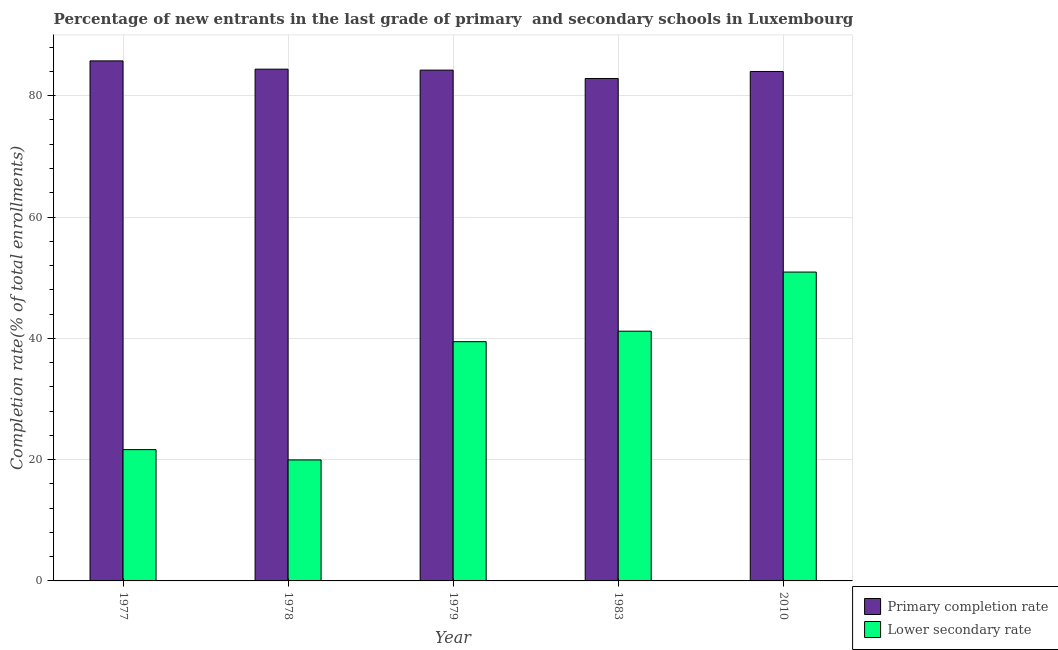How many groups of bars are there?
Your answer should be compact. 5. Are the number of bars per tick equal to the number of legend labels?
Keep it short and to the point. Yes. How many bars are there on the 5th tick from the right?
Provide a short and direct response. 2. What is the completion rate in primary schools in 1978?
Provide a succinct answer. 84.38. Across all years, what is the maximum completion rate in primary schools?
Your answer should be compact. 85.74. Across all years, what is the minimum completion rate in secondary schools?
Offer a terse response. 19.95. In which year was the completion rate in secondary schools minimum?
Your answer should be very brief. 1978. What is the total completion rate in secondary schools in the graph?
Keep it short and to the point. 173.15. What is the difference between the completion rate in secondary schools in 1977 and that in 2010?
Keep it short and to the point. -29.27. What is the difference between the completion rate in secondary schools in 1977 and the completion rate in primary schools in 1983?
Your response must be concise. -19.53. What is the average completion rate in primary schools per year?
Provide a succinct answer. 84.24. In the year 2010, what is the difference between the completion rate in secondary schools and completion rate in primary schools?
Your response must be concise. 0. In how many years, is the completion rate in secondary schools greater than 48 %?
Your answer should be compact. 1. What is the ratio of the completion rate in secondary schools in 1977 to that in 1978?
Ensure brevity in your answer.  1.09. Is the completion rate in primary schools in 1979 less than that in 2010?
Ensure brevity in your answer.  No. What is the difference between the highest and the second highest completion rate in primary schools?
Offer a terse response. 1.37. What is the difference between the highest and the lowest completion rate in secondary schools?
Your answer should be compact. 30.97. Is the sum of the completion rate in secondary schools in 1977 and 2010 greater than the maximum completion rate in primary schools across all years?
Offer a terse response. Yes. What does the 1st bar from the left in 1983 represents?
Provide a succinct answer. Primary completion rate. What does the 2nd bar from the right in 1979 represents?
Your answer should be compact. Primary completion rate. How many bars are there?
Give a very brief answer. 10. How many years are there in the graph?
Keep it short and to the point. 5. What is the difference between two consecutive major ticks on the Y-axis?
Your answer should be very brief. 20. Does the graph contain any zero values?
Offer a very short reply. No. Does the graph contain grids?
Provide a short and direct response. Yes. How many legend labels are there?
Ensure brevity in your answer.  2. How are the legend labels stacked?
Offer a terse response. Vertical. What is the title of the graph?
Your answer should be very brief. Percentage of new entrants in the last grade of primary  and secondary schools in Luxembourg. Does "Passenger Transport Items" appear as one of the legend labels in the graph?
Keep it short and to the point. No. What is the label or title of the X-axis?
Make the answer very short. Year. What is the label or title of the Y-axis?
Your answer should be compact. Completion rate(% of total enrollments). What is the Completion rate(% of total enrollments) of Primary completion rate in 1977?
Provide a succinct answer. 85.74. What is the Completion rate(% of total enrollments) of Lower secondary rate in 1977?
Keep it short and to the point. 21.65. What is the Completion rate(% of total enrollments) of Primary completion rate in 1978?
Make the answer very short. 84.38. What is the Completion rate(% of total enrollments) of Lower secondary rate in 1978?
Ensure brevity in your answer.  19.95. What is the Completion rate(% of total enrollments) of Primary completion rate in 1979?
Offer a terse response. 84.22. What is the Completion rate(% of total enrollments) of Lower secondary rate in 1979?
Your answer should be compact. 39.45. What is the Completion rate(% of total enrollments) of Primary completion rate in 1983?
Provide a succinct answer. 82.84. What is the Completion rate(% of total enrollments) of Lower secondary rate in 1983?
Make the answer very short. 41.18. What is the Completion rate(% of total enrollments) of Primary completion rate in 2010?
Your answer should be very brief. 84. What is the Completion rate(% of total enrollments) in Lower secondary rate in 2010?
Your answer should be very brief. 50.92. Across all years, what is the maximum Completion rate(% of total enrollments) in Primary completion rate?
Your response must be concise. 85.74. Across all years, what is the maximum Completion rate(% of total enrollments) of Lower secondary rate?
Provide a succinct answer. 50.92. Across all years, what is the minimum Completion rate(% of total enrollments) in Primary completion rate?
Offer a terse response. 82.84. Across all years, what is the minimum Completion rate(% of total enrollments) in Lower secondary rate?
Your answer should be compact. 19.95. What is the total Completion rate(% of total enrollments) of Primary completion rate in the graph?
Your response must be concise. 421.18. What is the total Completion rate(% of total enrollments) in Lower secondary rate in the graph?
Provide a succinct answer. 173.15. What is the difference between the Completion rate(% of total enrollments) of Primary completion rate in 1977 and that in 1978?
Offer a very short reply. 1.37. What is the difference between the Completion rate(% of total enrollments) of Lower secondary rate in 1977 and that in 1978?
Provide a short and direct response. 1.7. What is the difference between the Completion rate(% of total enrollments) in Primary completion rate in 1977 and that in 1979?
Provide a short and direct response. 1.52. What is the difference between the Completion rate(% of total enrollments) in Lower secondary rate in 1977 and that in 1979?
Keep it short and to the point. -17.8. What is the difference between the Completion rate(% of total enrollments) in Primary completion rate in 1977 and that in 1983?
Offer a terse response. 2.9. What is the difference between the Completion rate(% of total enrollments) in Lower secondary rate in 1977 and that in 1983?
Ensure brevity in your answer.  -19.53. What is the difference between the Completion rate(% of total enrollments) of Primary completion rate in 1977 and that in 2010?
Keep it short and to the point. 1.75. What is the difference between the Completion rate(% of total enrollments) of Lower secondary rate in 1977 and that in 2010?
Make the answer very short. -29.27. What is the difference between the Completion rate(% of total enrollments) in Primary completion rate in 1978 and that in 1979?
Your response must be concise. 0.15. What is the difference between the Completion rate(% of total enrollments) of Lower secondary rate in 1978 and that in 1979?
Offer a very short reply. -19.5. What is the difference between the Completion rate(% of total enrollments) of Primary completion rate in 1978 and that in 1983?
Ensure brevity in your answer.  1.54. What is the difference between the Completion rate(% of total enrollments) in Lower secondary rate in 1978 and that in 1983?
Give a very brief answer. -21.22. What is the difference between the Completion rate(% of total enrollments) of Primary completion rate in 1978 and that in 2010?
Give a very brief answer. 0.38. What is the difference between the Completion rate(% of total enrollments) of Lower secondary rate in 1978 and that in 2010?
Provide a succinct answer. -30.97. What is the difference between the Completion rate(% of total enrollments) of Primary completion rate in 1979 and that in 1983?
Keep it short and to the point. 1.38. What is the difference between the Completion rate(% of total enrollments) in Lower secondary rate in 1979 and that in 1983?
Offer a terse response. -1.73. What is the difference between the Completion rate(% of total enrollments) of Primary completion rate in 1979 and that in 2010?
Offer a terse response. 0.23. What is the difference between the Completion rate(% of total enrollments) in Lower secondary rate in 1979 and that in 2010?
Your answer should be very brief. -11.48. What is the difference between the Completion rate(% of total enrollments) in Primary completion rate in 1983 and that in 2010?
Offer a terse response. -1.16. What is the difference between the Completion rate(% of total enrollments) in Lower secondary rate in 1983 and that in 2010?
Provide a short and direct response. -9.75. What is the difference between the Completion rate(% of total enrollments) of Primary completion rate in 1977 and the Completion rate(% of total enrollments) of Lower secondary rate in 1978?
Your response must be concise. 65.79. What is the difference between the Completion rate(% of total enrollments) in Primary completion rate in 1977 and the Completion rate(% of total enrollments) in Lower secondary rate in 1979?
Your answer should be very brief. 46.3. What is the difference between the Completion rate(% of total enrollments) in Primary completion rate in 1977 and the Completion rate(% of total enrollments) in Lower secondary rate in 1983?
Your answer should be very brief. 44.57. What is the difference between the Completion rate(% of total enrollments) in Primary completion rate in 1977 and the Completion rate(% of total enrollments) in Lower secondary rate in 2010?
Keep it short and to the point. 34.82. What is the difference between the Completion rate(% of total enrollments) in Primary completion rate in 1978 and the Completion rate(% of total enrollments) in Lower secondary rate in 1979?
Keep it short and to the point. 44.93. What is the difference between the Completion rate(% of total enrollments) in Primary completion rate in 1978 and the Completion rate(% of total enrollments) in Lower secondary rate in 1983?
Provide a succinct answer. 43.2. What is the difference between the Completion rate(% of total enrollments) of Primary completion rate in 1978 and the Completion rate(% of total enrollments) of Lower secondary rate in 2010?
Give a very brief answer. 33.45. What is the difference between the Completion rate(% of total enrollments) in Primary completion rate in 1979 and the Completion rate(% of total enrollments) in Lower secondary rate in 1983?
Ensure brevity in your answer.  43.05. What is the difference between the Completion rate(% of total enrollments) of Primary completion rate in 1979 and the Completion rate(% of total enrollments) of Lower secondary rate in 2010?
Make the answer very short. 33.3. What is the difference between the Completion rate(% of total enrollments) in Primary completion rate in 1983 and the Completion rate(% of total enrollments) in Lower secondary rate in 2010?
Provide a succinct answer. 31.92. What is the average Completion rate(% of total enrollments) of Primary completion rate per year?
Your answer should be compact. 84.24. What is the average Completion rate(% of total enrollments) of Lower secondary rate per year?
Ensure brevity in your answer.  34.63. In the year 1977, what is the difference between the Completion rate(% of total enrollments) in Primary completion rate and Completion rate(% of total enrollments) in Lower secondary rate?
Keep it short and to the point. 64.09. In the year 1978, what is the difference between the Completion rate(% of total enrollments) in Primary completion rate and Completion rate(% of total enrollments) in Lower secondary rate?
Your answer should be compact. 64.43. In the year 1979, what is the difference between the Completion rate(% of total enrollments) in Primary completion rate and Completion rate(% of total enrollments) in Lower secondary rate?
Provide a short and direct response. 44.77. In the year 1983, what is the difference between the Completion rate(% of total enrollments) in Primary completion rate and Completion rate(% of total enrollments) in Lower secondary rate?
Offer a terse response. 41.67. In the year 2010, what is the difference between the Completion rate(% of total enrollments) in Primary completion rate and Completion rate(% of total enrollments) in Lower secondary rate?
Your answer should be compact. 33.07. What is the ratio of the Completion rate(% of total enrollments) of Primary completion rate in 1977 to that in 1978?
Your answer should be compact. 1.02. What is the ratio of the Completion rate(% of total enrollments) in Lower secondary rate in 1977 to that in 1978?
Your answer should be compact. 1.09. What is the ratio of the Completion rate(% of total enrollments) in Primary completion rate in 1977 to that in 1979?
Make the answer very short. 1.02. What is the ratio of the Completion rate(% of total enrollments) in Lower secondary rate in 1977 to that in 1979?
Your answer should be compact. 0.55. What is the ratio of the Completion rate(% of total enrollments) of Primary completion rate in 1977 to that in 1983?
Offer a very short reply. 1.03. What is the ratio of the Completion rate(% of total enrollments) of Lower secondary rate in 1977 to that in 1983?
Ensure brevity in your answer.  0.53. What is the ratio of the Completion rate(% of total enrollments) of Primary completion rate in 1977 to that in 2010?
Offer a terse response. 1.02. What is the ratio of the Completion rate(% of total enrollments) of Lower secondary rate in 1977 to that in 2010?
Your answer should be compact. 0.43. What is the ratio of the Completion rate(% of total enrollments) of Primary completion rate in 1978 to that in 1979?
Your answer should be very brief. 1. What is the ratio of the Completion rate(% of total enrollments) of Lower secondary rate in 1978 to that in 1979?
Ensure brevity in your answer.  0.51. What is the ratio of the Completion rate(% of total enrollments) in Primary completion rate in 1978 to that in 1983?
Provide a succinct answer. 1.02. What is the ratio of the Completion rate(% of total enrollments) of Lower secondary rate in 1978 to that in 1983?
Offer a very short reply. 0.48. What is the ratio of the Completion rate(% of total enrollments) in Primary completion rate in 1978 to that in 2010?
Give a very brief answer. 1. What is the ratio of the Completion rate(% of total enrollments) of Lower secondary rate in 1978 to that in 2010?
Give a very brief answer. 0.39. What is the ratio of the Completion rate(% of total enrollments) of Primary completion rate in 1979 to that in 1983?
Your answer should be very brief. 1.02. What is the ratio of the Completion rate(% of total enrollments) in Lower secondary rate in 1979 to that in 1983?
Offer a very short reply. 0.96. What is the ratio of the Completion rate(% of total enrollments) in Lower secondary rate in 1979 to that in 2010?
Offer a very short reply. 0.77. What is the ratio of the Completion rate(% of total enrollments) in Primary completion rate in 1983 to that in 2010?
Keep it short and to the point. 0.99. What is the ratio of the Completion rate(% of total enrollments) of Lower secondary rate in 1983 to that in 2010?
Provide a short and direct response. 0.81. What is the difference between the highest and the second highest Completion rate(% of total enrollments) in Primary completion rate?
Offer a very short reply. 1.37. What is the difference between the highest and the second highest Completion rate(% of total enrollments) in Lower secondary rate?
Offer a terse response. 9.75. What is the difference between the highest and the lowest Completion rate(% of total enrollments) of Primary completion rate?
Offer a terse response. 2.9. What is the difference between the highest and the lowest Completion rate(% of total enrollments) of Lower secondary rate?
Give a very brief answer. 30.97. 